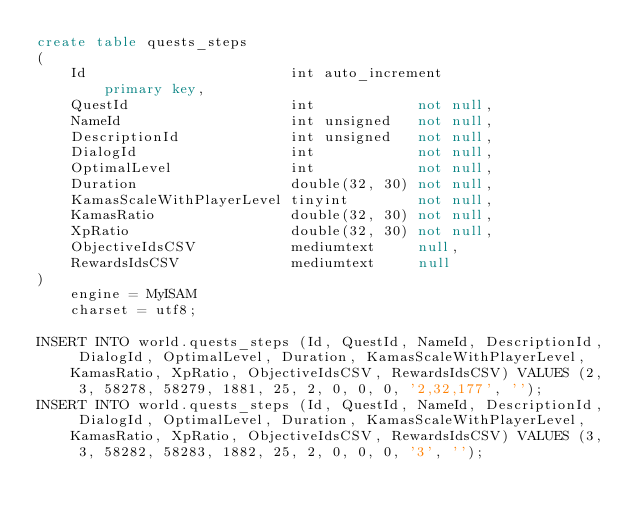<code> <loc_0><loc_0><loc_500><loc_500><_SQL_>create table quests_steps
(
    Id                        int auto_increment
        primary key,
    QuestId                   int            not null,
    NameId                    int unsigned   not null,
    DescriptionId             int unsigned   not null,
    DialogId                  int            not null,
    OptimalLevel              int            not null,
    Duration                  double(32, 30) not null,
    KamasScaleWithPlayerLevel tinyint        not null,
    KamasRatio                double(32, 30) not null,
    XpRatio                   double(32, 30) not null,
    ObjectiveIdsCSV           mediumtext     null,
    RewardsIdsCSV             mediumtext     null
)
    engine = MyISAM
    charset = utf8;

INSERT INTO world.quests_steps (Id, QuestId, NameId, DescriptionId, DialogId, OptimalLevel, Duration, KamasScaleWithPlayerLevel, KamasRatio, XpRatio, ObjectiveIdsCSV, RewardsIdsCSV) VALUES (2, 3, 58278, 58279, 1881, 25, 2, 0, 0, 0, '2,32,177', '');
INSERT INTO world.quests_steps (Id, QuestId, NameId, DescriptionId, DialogId, OptimalLevel, Duration, KamasScaleWithPlayerLevel, KamasRatio, XpRatio, ObjectiveIdsCSV, RewardsIdsCSV) VALUES (3, 3, 58282, 58283, 1882, 25, 2, 0, 0, 0, '3', '');</code> 